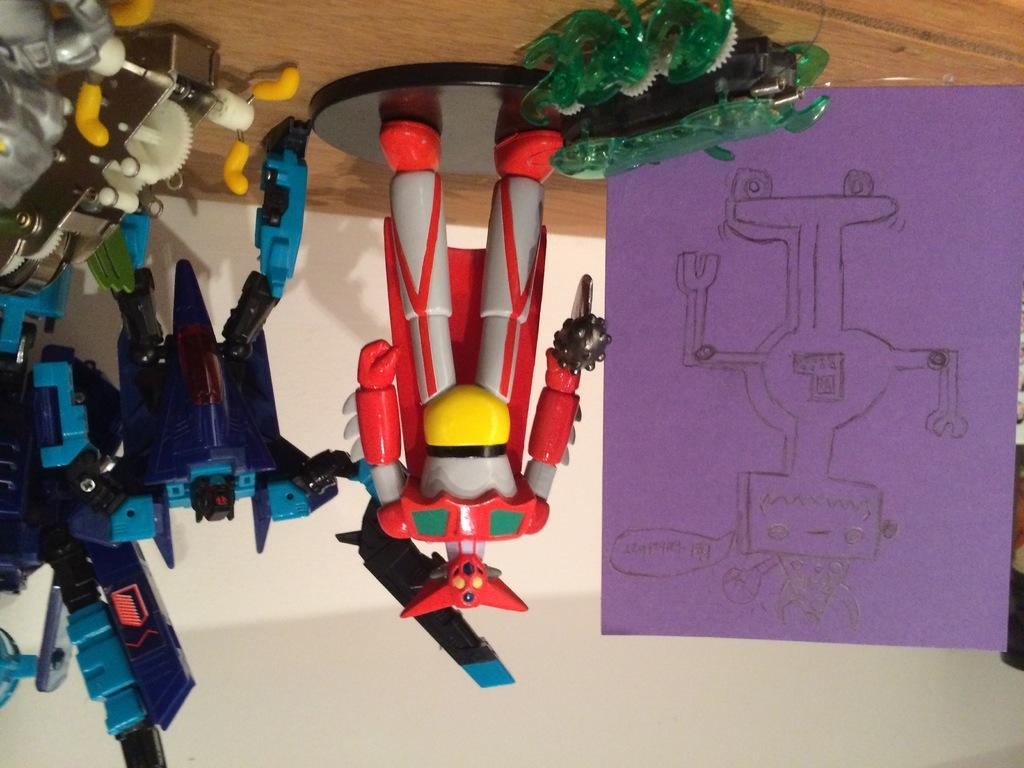What is located in the center of the image? There are different color toys and paper in the center of the image. Can you describe the toys in the image? The toys are of different colors, but their specific shapes or types are not mentioned in the facts. What is visible in the background of the image? There is a wall in the background of the image. Can you see the sun shining on the toys in the image? The facts provided do not mention the sun or any lighting conditions, so we cannot determine if the sun is shining on the toys in the image. 